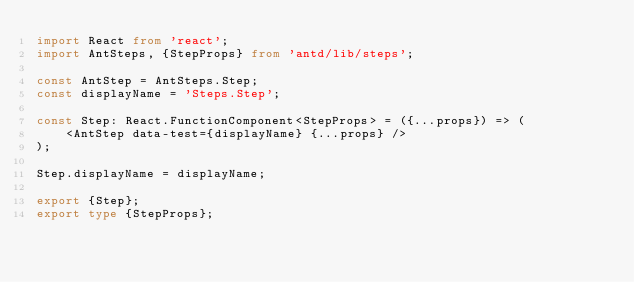Convert code to text. <code><loc_0><loc_0><loc_500><loc_500><_TypeScript_>import React from 'react';
import AntSteps, {StepProps} from 'antd/lib/steps';

const AntStep = AntSteps.Step;
const displayName = 'Steps.Step';

const Step: React.FunctionComponent<StepProps> = ({...props}) => (
    <AntStep data-test={displayName} {...props} />
);

Step.displayName = displayName;

export {Step};
export type {StepProps};
</code> 